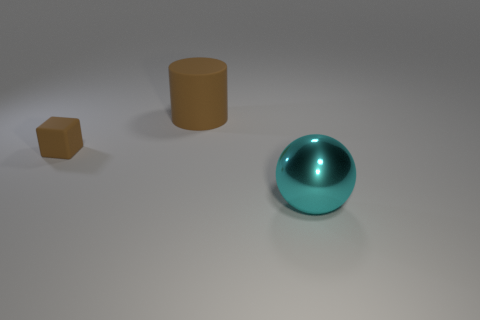Add 1 large matte cylinders. How many objects exist? 4 Subtract all blocks. How many objects are left? 2 Add 3 big matte things. How many big matte things are left? 4 Add 3 large cyan metal objects. How many large cyan metal objects exist? 4 Subtract 0 yellow spheres. How many objects are left? 3 Subtract all red balls. Subtract all gray blocks. How many balls are left? 1 Subtract all green matte blocks. Subtract all tiny brown blocks. How many objects are left? 2 